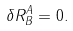<formula> <loc_0><loc_0><loc_500><loc_500>\delta R _ { B } ^ { A } = 0 .</formula> 